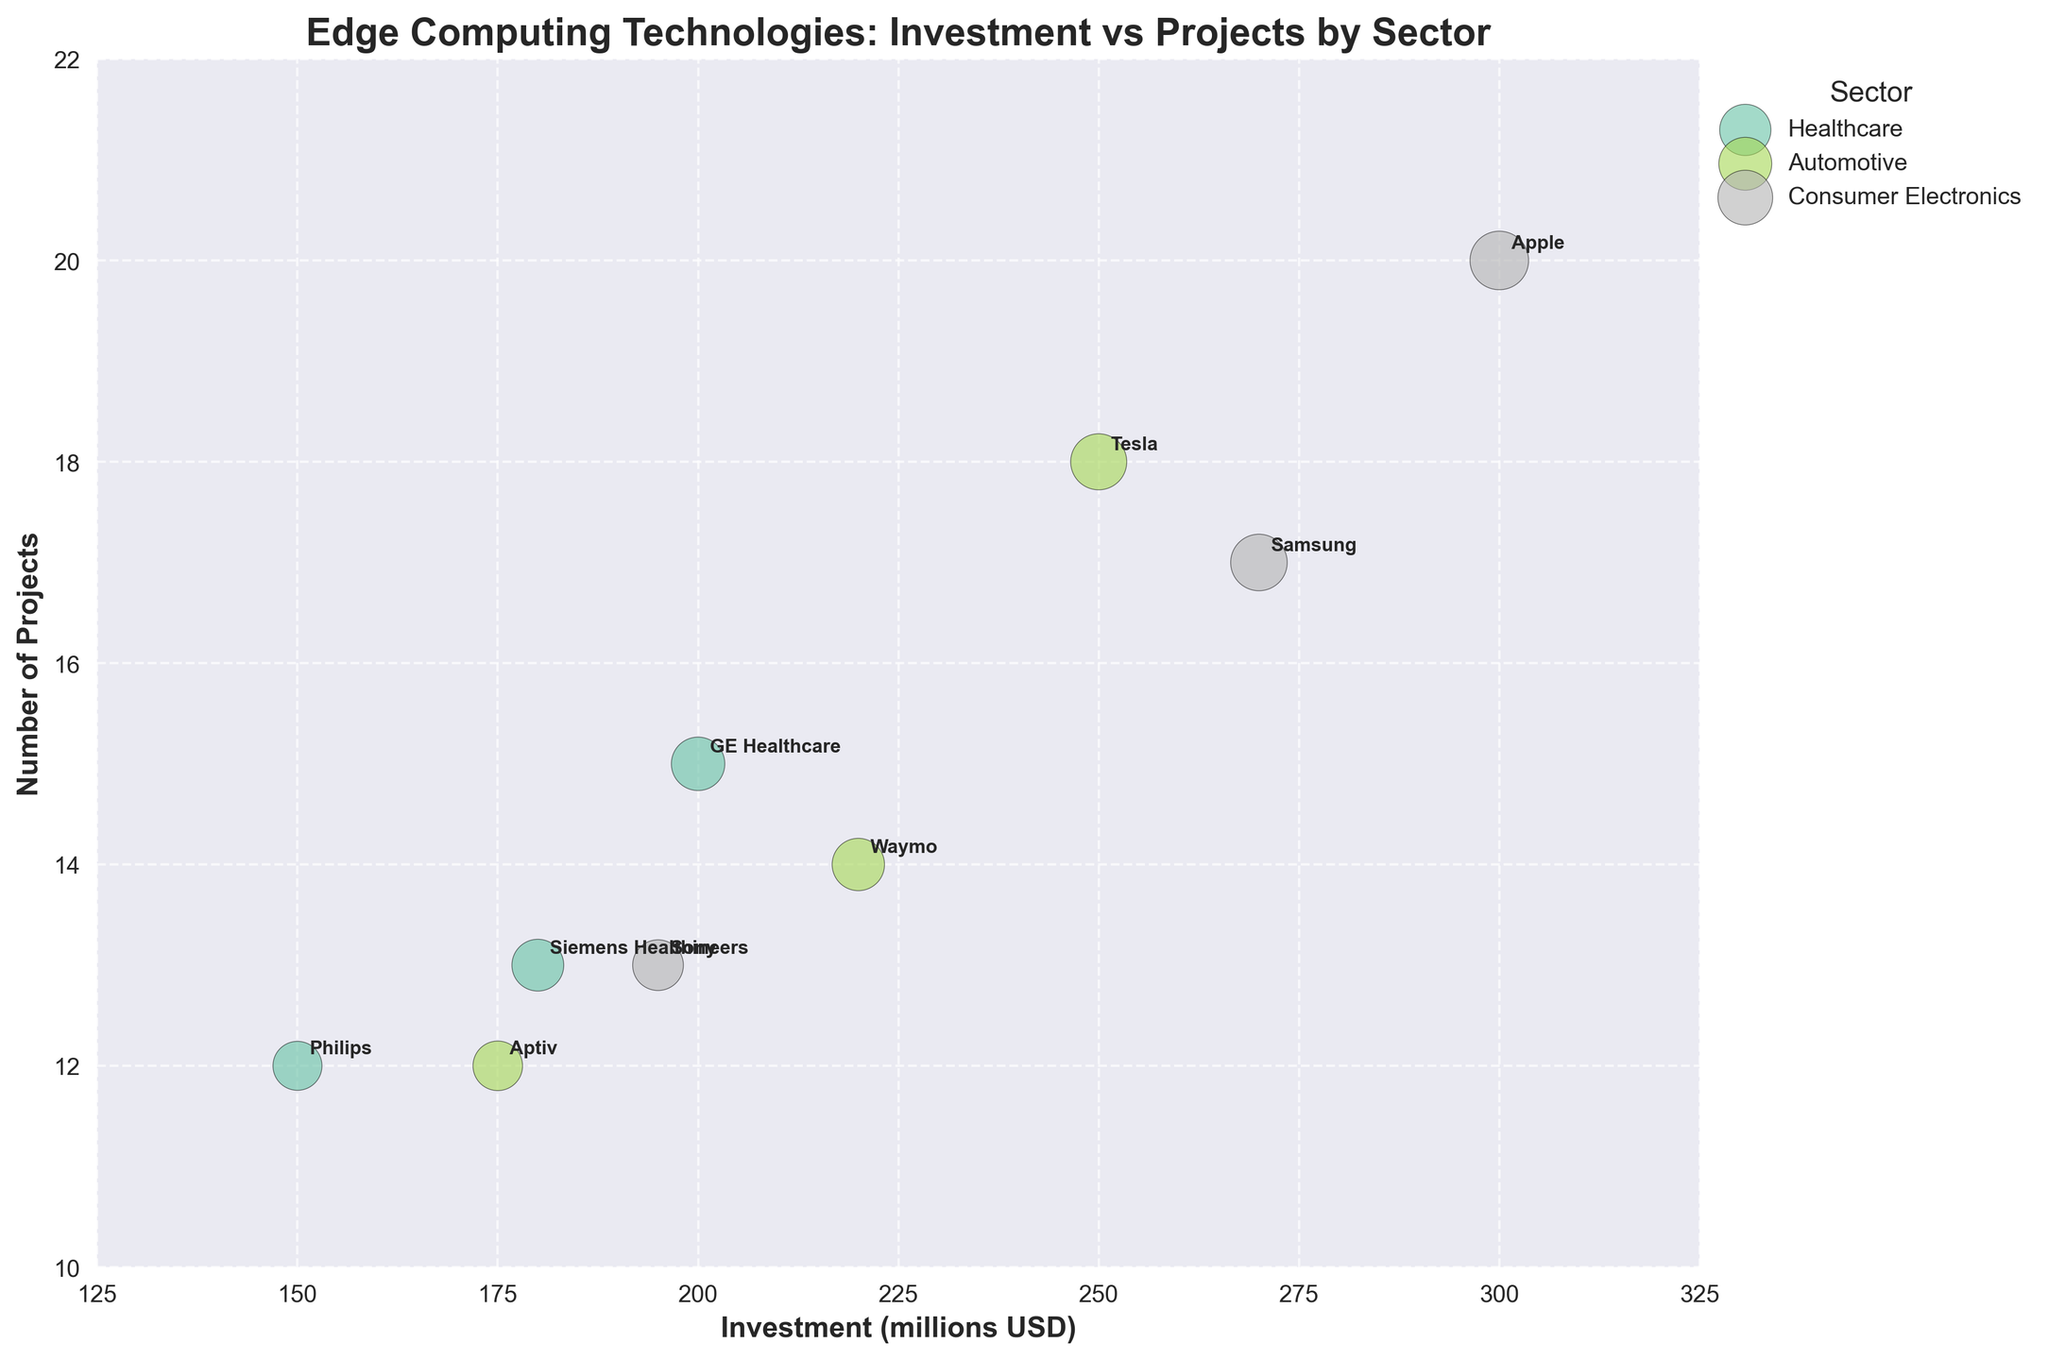How many sectors are represented in the bubble chart? The bubble chart visually differentiates bubbles by color for each sector, and there are three distinct colors visible. This indicates three sectors.
Answer: 3 Which company in the healthcare sector has the highest number of projects? In the healthcare sector, you can find the number of projects plotted along the y-axis. Among the healthcare companies (Philips, GE Healthcare, Siemens Healthineers), GE Healthcare is positioned highest on the y-axis.
Answer: GE Healthcare What is the total investment by all companies in the automotive sector? Add up the investments for each company in the automotive sector (Tesla: 250, Aptiv: 175, Waymo: 220). The total is 250 + 175 + 220.
Answer: 645 million USD Which sector has the company with the largest bubble size? The bubble size represents specific data values, and among the sectors, the largest bubble is for Apple in consumer electronics.
Answer: Consumer Electronics How does the investment of Tesla compare to that of Apple? Tesla (automotive) has an investment of 250 million USD, whereas Apple (consumer electronics) has an investment of 300 million USD. Apple’s investment is higher.
Answer: Apple's investment is higher What is the average number of projects for companies in the consumer electronics sector? Add the number of projects for each company in the consumer electronics sector (Apple: 20, Samsung: 17, Sony: 13) and then divide by the number of companies (3). The average is (20 + 17 + 13) / 3.
Answer: 16.7 projects Which automotive company has the smallest bubble size and how many projects do they have? In the automotive sector, compare the bubble sizes of Tesla, Aptiv, and Waymo. Aptiv has the smallest bubble size. The number of projects for Aptiv is 12.
Answer: Aptiv, 12 projects What is the combined number of projects for GE Healthcare and Siemens Healthineers? Add the number of projects for each company: GE Healthcare (15) + Siemens Healthineers (13). The combined total is 15 + 13.
Answer: 28 projects Among all sectors, which company has invested the least amount in edge computing technologies? Find the company with the smallest investment value on the x-axis. Philips (healthcare) has the smallest investment of 150 million USD.
Answer: Philips How many companies have more than 15 projects? Identify bubbles corresponding to more than 15 projects on the y-axis. Companies with more than 15 projects are Tesla, Apple, Samsung.
Answer: 3 companies 